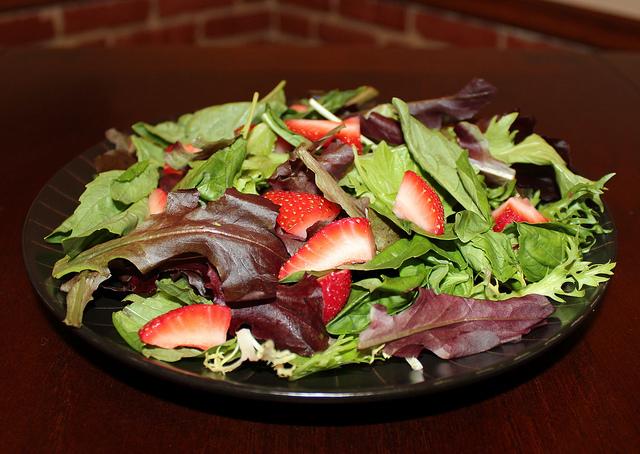Is there any Broccoli in this picture?
Write a very short answer. No. What orange vegetable is in the bowl?
Answer briefly. None. Is this a summer salad?
Write a very short answer. Yes. Is this a scrambled egg dish?
Answer briefly. No. Are they making pizza?
Answer briefly. No. What is the shape of the plate?
Write a very short answer. Round. What color is the lettuce?
Write a very short answer. Green. Is this cooked?
Write a very short answer. No. Which type of food is this?
Short answer required. Salad. What are the green florets?
Keep it brief. Lettuce. Are there eggs in this salad?
Give a very brief answer. No. Is this a vegetarian meal?
Be succinct. Yes. What are the red objects?
Short answer required. Strawberries. What is the color of the plate?
Answer briefly. Black. What fruit is on this salad?
Quick response, please. Strawberry. What color is the plate?
Quick response, please. Black. How many different ingredients are in the salad?
Write a very short answer. 3. Are there only fruits on the plate?
Keep it brief. No. Does the salad have cheese?
Be succinct. No. What color is the food?
Keep it brief. Green. Does this picture have a shallow depth of field?
Short answer required. Yes. What is green on the plate?
Answer briefly. Lettuce. What is the green vegetable?
Be succinct. Lettuce. What food is this?
Write a very short answer. Salad. What is the green vegetable on the plate?
Write a very short answer. Lettuce. What is the color of the bowl in this picture?
Quick response, please. Black. What vegetable is green in the bowl?
Concise answer only. Lettuce. Is there lettuce?
Short answer required. Yes. How many different toppings does the salad have?
Write a very short answer. 1. Is this a pasta dish?
Short answer required. No. Does the appear to be cooked?
Quick response, please. No. What is on top of the salad?
Concise answer only. Strawberries. 